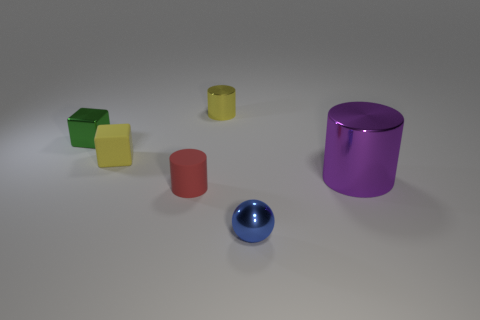Add 3 tiny yellow things. How many objects exist? 9 Subtract all yellow cylinders. How many cylinders are left? 2 Subtract 0 cyan spheres. How many objects are left? 6 Subtract all cubes. How many objects are left? 4 Subtract all green cubes. Subtract all red cylinders. How many cubes are left? 1 Subtract all purple cylinders. How many purple balls are left? 0 Subtract all blocks. Subtract all cubes. How many objects are left? 2 Add 5 small cubes. How many small cubes are left? 7 Add 6 small rubber cubes. How many small rubber cubes exist? 7 Subtract all green cubes. How many cubes are left? 1 